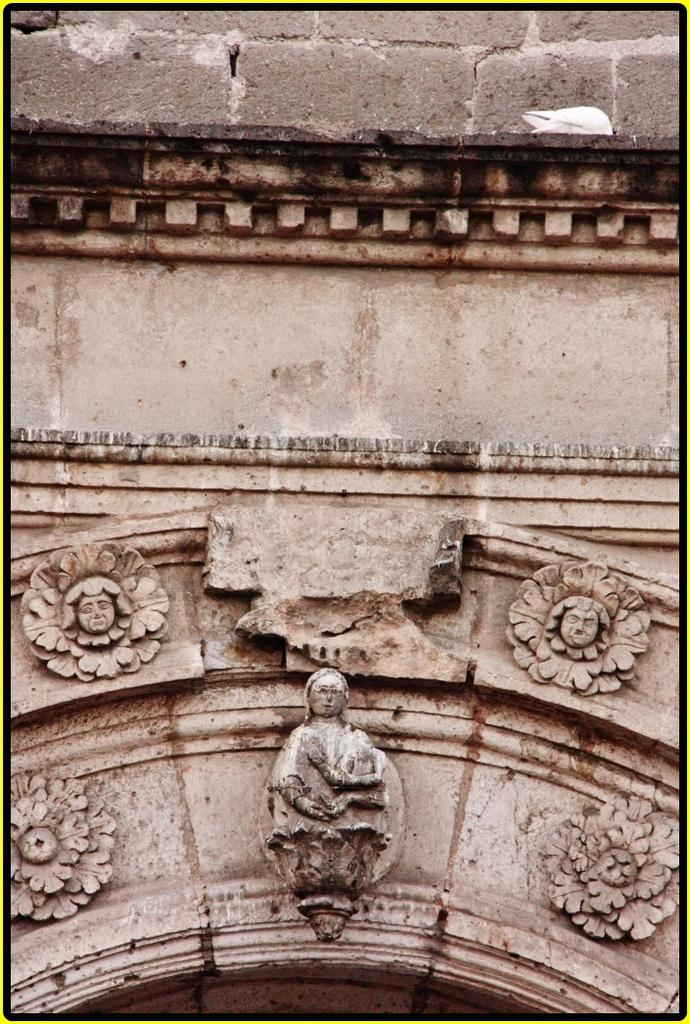What type of artwork can be seen on the wall in the image? There are sculptures on the wall in the image. Can you describe the sculptures in more detail? Unfortunately, the image does not provide enough detail to describe the sculptures further. What might be the purpose of having sculptures on the wall? The sculptures on the wall could serve as decoration or as a representation of a particular theme or idea. What type of oil is being used to create the eggnog in the image? There is no mention of eggnog or oil in the image, as it only features sculptures on the wall. 